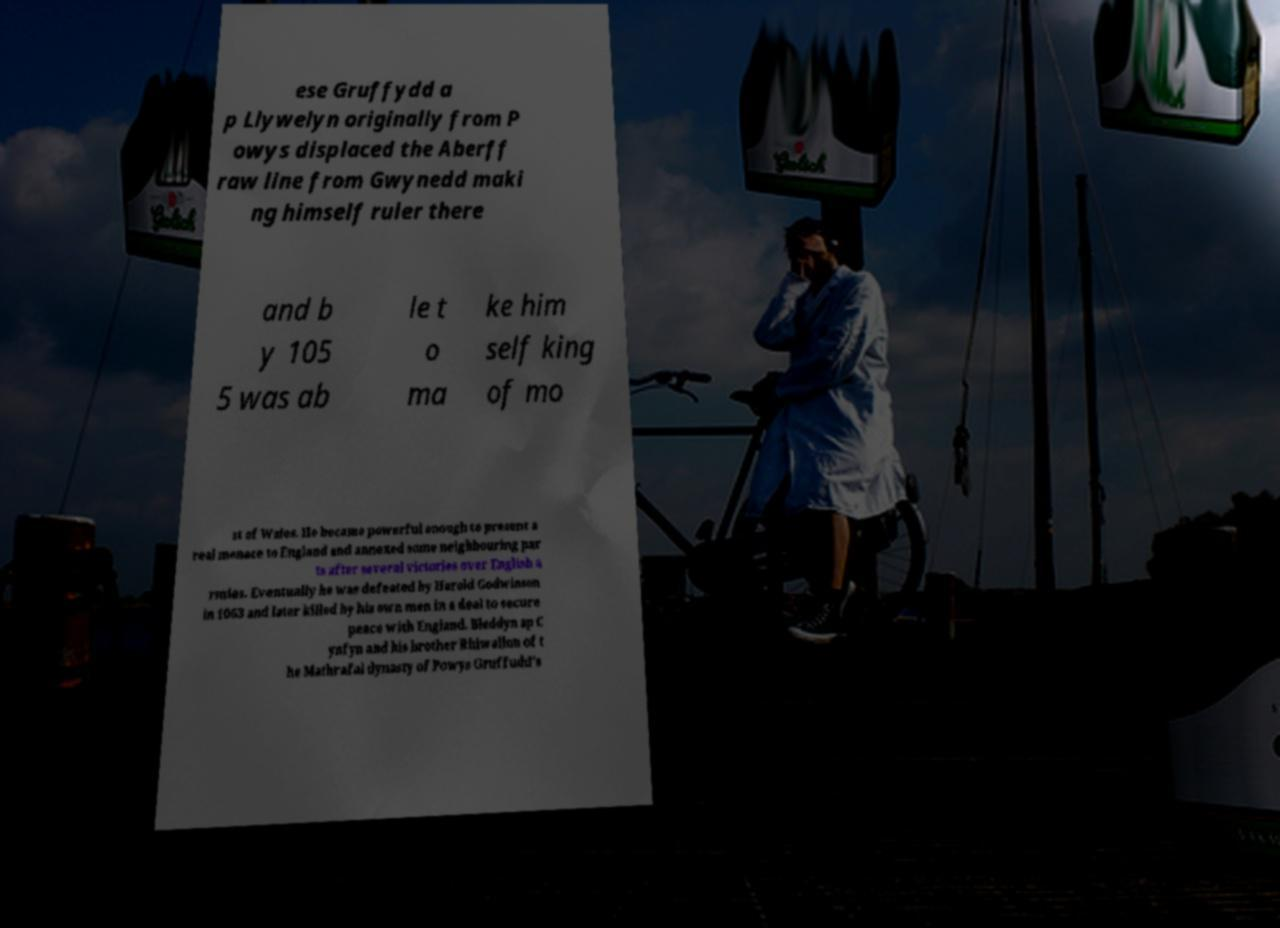For documentation purposes, I need the text within this image transcribed. Could you provide that? ese Gruffydd a p Llywelyn originally from P owys displaced the Aberff raw line from Gwynedd maki ng himself ruler there and b y 105 5 was ab le t o ma ke him self king of mo st of Wales. He became powerful enough to present a real menace to England and annexed some neighbouring par ts after several victories over English a rmies. Eventually he was defeated by Harold Godwinson in 1063 and later killed by his own men in a deal to secure peace with England. Bleddyn ap C ynfyn and his brother Rhiwallon of t he Mathrafal dynasty of Powys Gruffudd's 